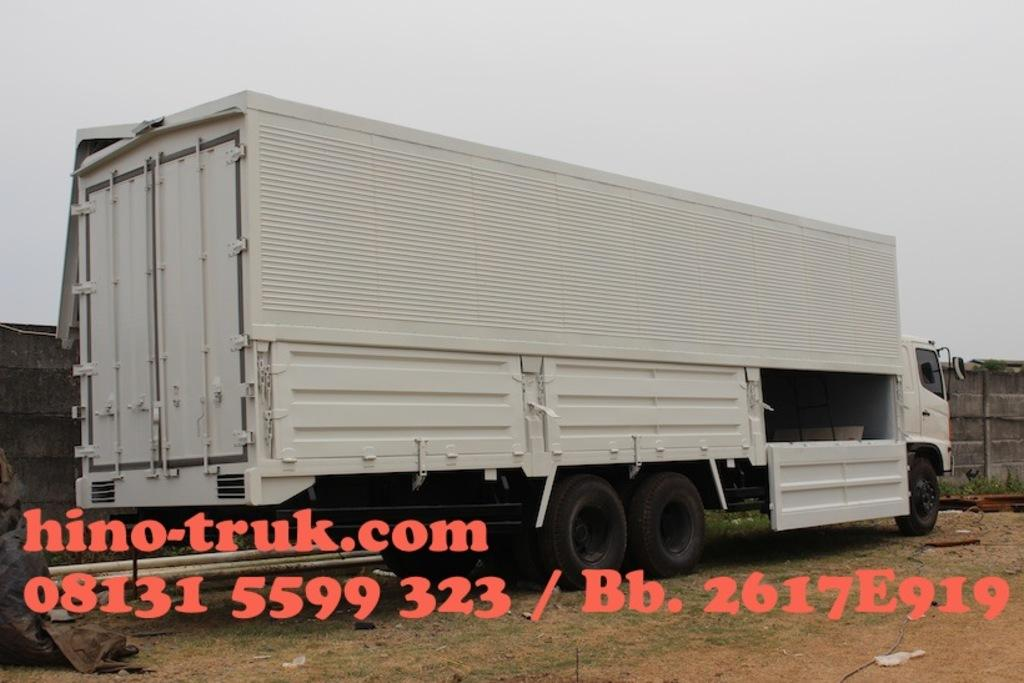What type of vehicle is in the image? There is a white color truck in the image. What is behind the truck in the image? There is a wall behind the truck. What can be seen above the truck in the image? The sky is visible in the image. What is the color of the sky in the image? The sky appears to be white in color. What is present at the bottom of the image? There is a watermark at the bottom of the image. What language is spoken by the powder on the moon in the image? There is no powder or moon present in the image, so this question cannot be answered. 